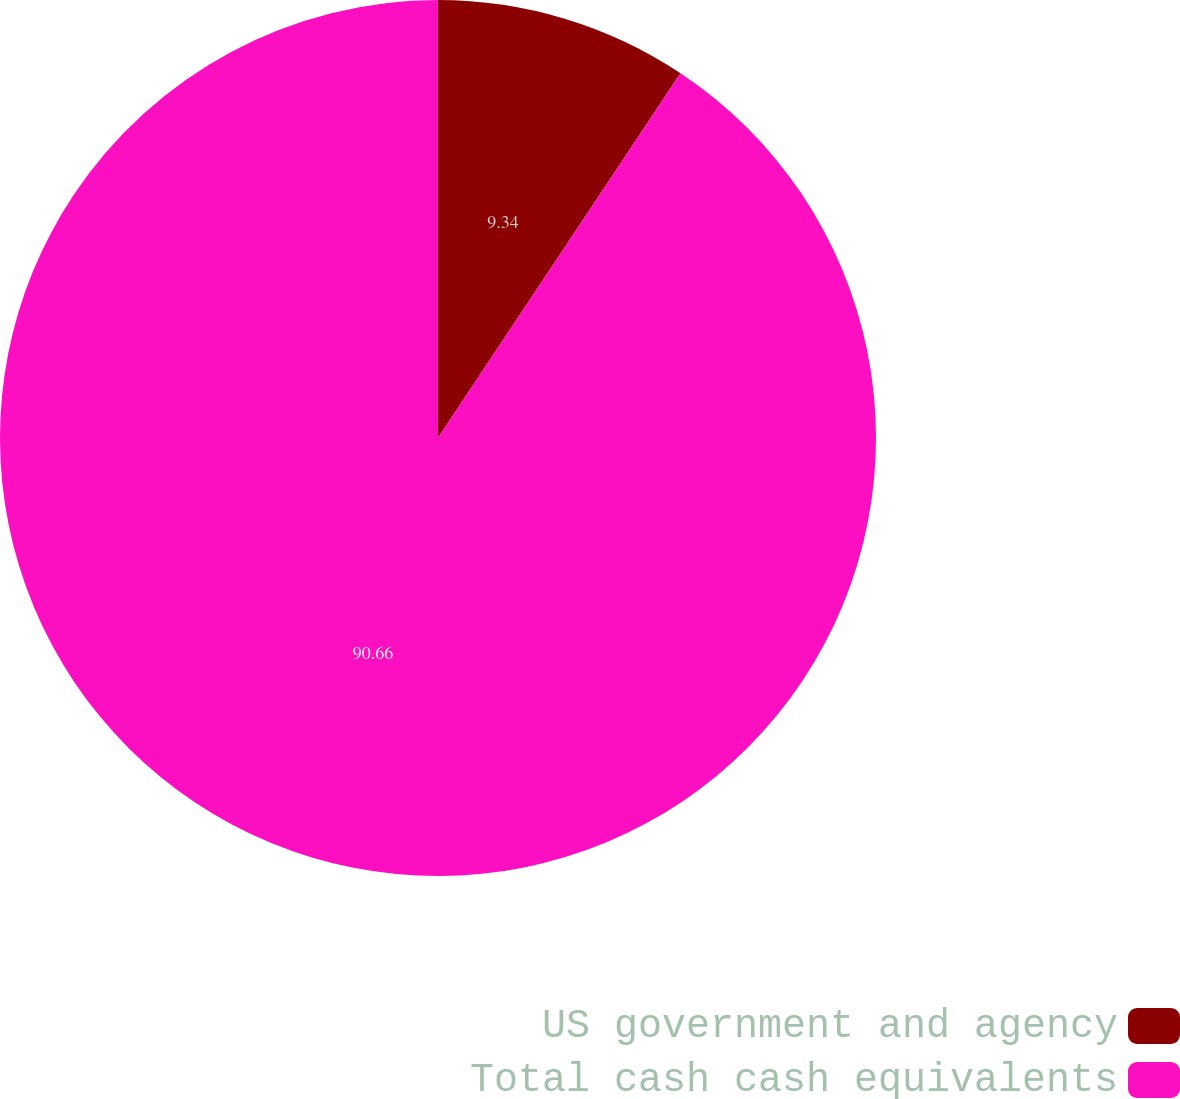Convert chart. <chart><loc_0><loc_0><loc_500><loc_500><pie_chart><fcel>US government and agency<fcel>Total cash cash equivalents<nl><fcel>9.34%<fcel>90.66%<nl></chart> 